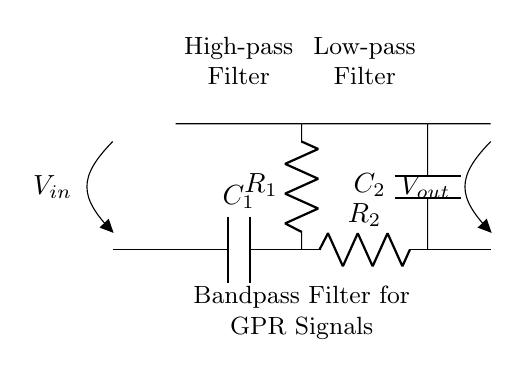What type of filter is this circuit? The circuit is a bandpass filter that allows a specific range of frequencies to pass while attenuating frequencies outside of this range. The presence of both high-pass and low-pass sections indicates it is designed to pass a band of frequencies.
Answer: Bandpass filter What component values are there in the high-pass filter section? In the high-pass filter section, there is a capacitor labeled C1 and a resistor labeled R1. The arrangement allows high-frequency signals to pass while blocking lower frequencies.
Answer: C1 and R1 What is the role of the capacitor in the low-pass filter section? The capacitor in the low-pass filter section (C2) allows low-frequency signals to pass and attenuates high-frequency signals. This behavior is typical for capacitors in low-pass configurations where they provide a path to ground for high-frequency noise.
Answer: Attenuation of high frequencies How are the high-pass and low-pass filters connected? The high-pass and low-pass filters are connected in series, with the output of the high-pass connected to the input of the low-pass. This arrangement creates a bandpass characteristic by allowing only the frequencies that fall within the specified band to pass through.
Answer: Series connection What is the function of resistor R2 in this circuit? Resistor R2 in the low-pass filter section helps to determine the cutoff frequency of the low-pass filter, allowing specific low frequencies to pass while providing a path for high frequencies to be attenuated, thereby shaping the overall filter response.
Answer: Cutoff frequency adjustment What is the significance of the labels on the circuit diagram? The labels identify individual components (like R1, R2, C1, C2) and the voltages (Vin and Vout) in the circuit, providing crucial information for understanding how the circuit operates and what parameters are important in the design.
Answer: Component identification 